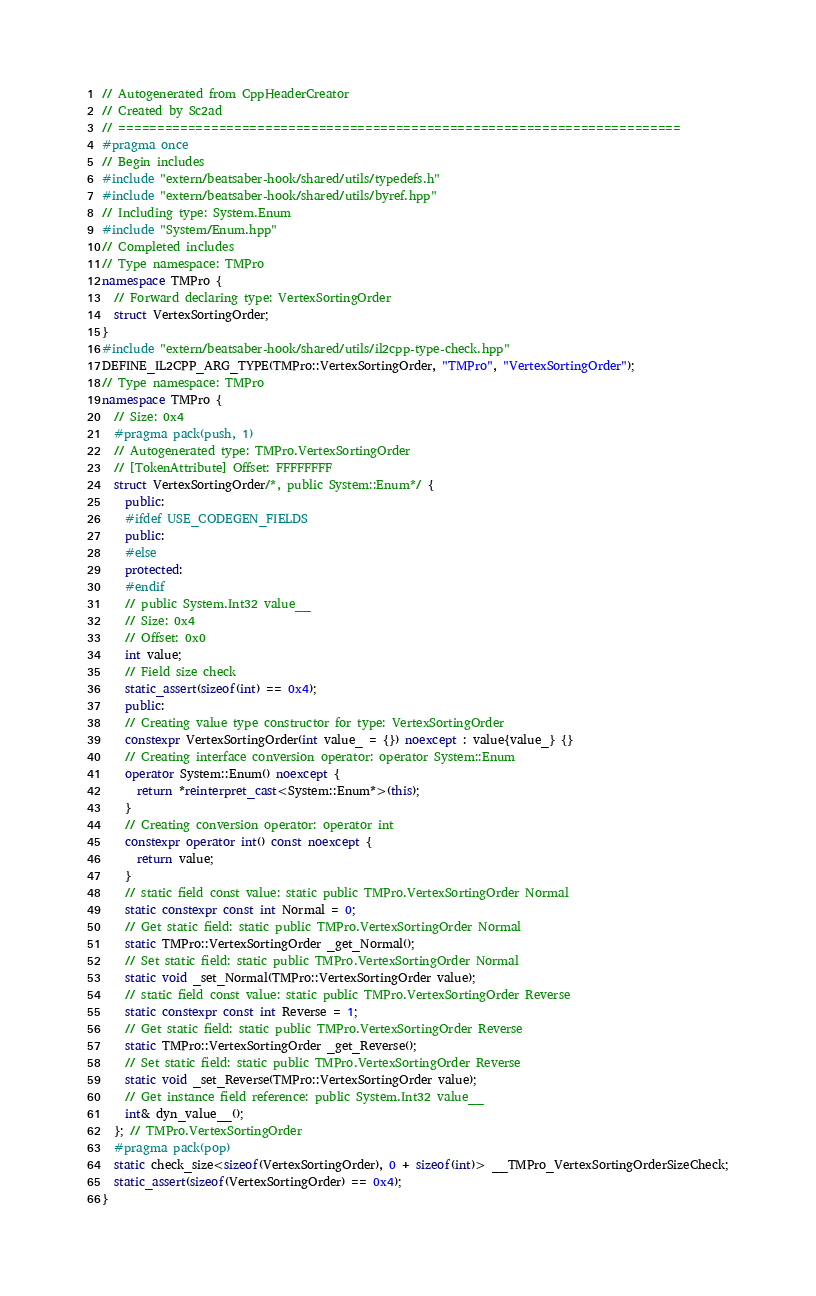Convert code to text. <code><loc_0><loc_0><loc_500><loc_500><_C++_>// Autogenerated from CppHeaderCreator
// Created by Sc2ad
// =========================================================================
#pragma once
// Begin includes
#include "extern/beatsaber-hook/shared/utils/typedefs.h"
#include "extern/beatsaber-hook/shared/utils/byref.hpp"
// Including type: System.Enum
#include "System/Enum.hpp"
// Completed includes
// Type namespace: TMPro
namespace TMPro {
  // Forward declaring type: VertexSortingOrder
  struct VertexSortingOrder;
}
#include "extern/beatsaber-hook/shared/utils/il2cpp-type-check.hpp"
DEFINE_IL2CPP_ARG_TYPE(TMPro::VertexSortingOrder, "TMPro", "VertexSortingOrder");
// Type namespace: TMPro
namespace TMPro {
  // Size: 0x4
  #pragma pack(push, 1)
  // Autogenerated type: TMPro.VertexSortingOrder
  // [TokenAttribute] Offset: FFFFFFFF
  struct VertexSortingOrder/*, public System::Enum*/ {
    public:
    #ifdef USE_CODEGEN_FIELDS
    public:
    #else
    protected:
    #endif
    // public System.Int32 value__
    // Size: 0x4
    // Offset: 0x0
    int value;
    // Field size check
    static_assert(sizeof(int) == 0x4);
    public:
    // Creating value type constructor for type: VertexSortingOrder
    constexpr VertexSortingOrder(int value_ = {}) noexcept : value{value_} {}
    // Creating interface conversion operator: operator System::Enum
    operator System::Enum() noexcept {
      return *reinterpret_cast<System::Enum*>(this);
    }
    // Creating conversion operator: operator int
    constexpr operator int() const noexcept {
      return value;
    }
    // static field const value: static public TMPro.VertexSortingOrder Normal
    static constexpr const int Normal = 0;
    // Get static field: static public TMPro.VertexSortingOrder Normal
    static TMPro::VertexSortingOrder _get_Normal();
    // Set static field: static public TMPro.VertexSortingOrder Normal
    static void _set_Normal(TMPro::VertexSortingOrder value);
    // static field const value: static public TMPro.VertexSortingOrder Reverse
    static constexpr const int Reverse = 1;
    // Get static field: static public TMPro.VertexSortingOrder Reverse
    static TMPro::VertexSortingOrder _get_Reverse();
    // Set static field: static public TMPro.VertexSortingOrder Reverse
    static void _set_Reverse(TMPro::VertexSortingOrder value);
    // Get instance field reference: public System.Int32 value__
    int& dyn_value__();
  }; // TMPro.VertexSortingOrder
  #pragma pack(pop)
  static check_size<sizeof(VertexSortingOrder), 0 + sizeof(int)> __TMPro_VertexSortingOrderSizeCheck;
  static_assert(sizeof(VertexSortingOrder) == 0x4);
}</code> 